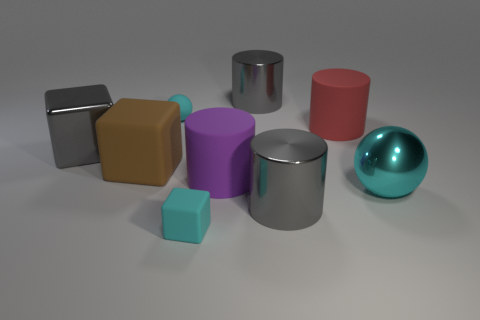Add 1 matte things. How many objects exist? 10 Subtract all cylinders. How many objects are left? 5 Subtract all tiny rubber blocks. How many blocks are left? 2 Subtract 4 cylinders. How many cylinders are left? 0 Subtract all yellow cubes. Subtract all gray cylinders. How many cubes are left? 3 Subtract all yellow blocks. How many red cylinders are left? 1 Subtract all big blue things. Subtract all large rubber things. How many objects are left? 6 Add 2 large gray metallic objects. How many large gray metallic objects are left? 5 Add 3 rubber balls. How many rubber balls exist? 4 Subtract all gray cylinders. How many cylinders are left? 2 